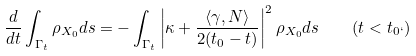<formula> <loc_0><loc_0><loc_500><loc_500>\frac { d } { d t } \int _ { \Gamma _ { t } } \rho _ { X _ { 0 } } d s = - \int _ { \Gamma _ { t } } \left | \kappa + \frac { \langle \gamma , N \rangle } { 2 ( t _ { 0 } - t ) } \right | ^ { 2 } \rho _ { X _ { 0 } } d s \quad ( t < t _ { 0 ` } )</formula> 